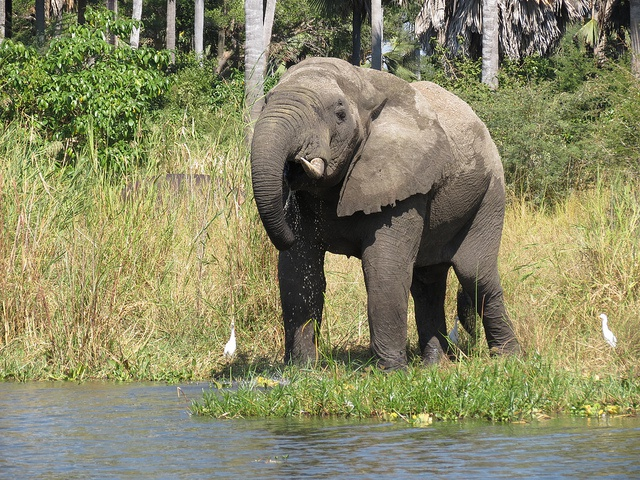Describe the objects in this image and their specific colors. I can see elephant in darkgray, black, and gray tones, bird in darkgray, white, and tan tones, and bird in darkgray, white, and tan tones in this image. 